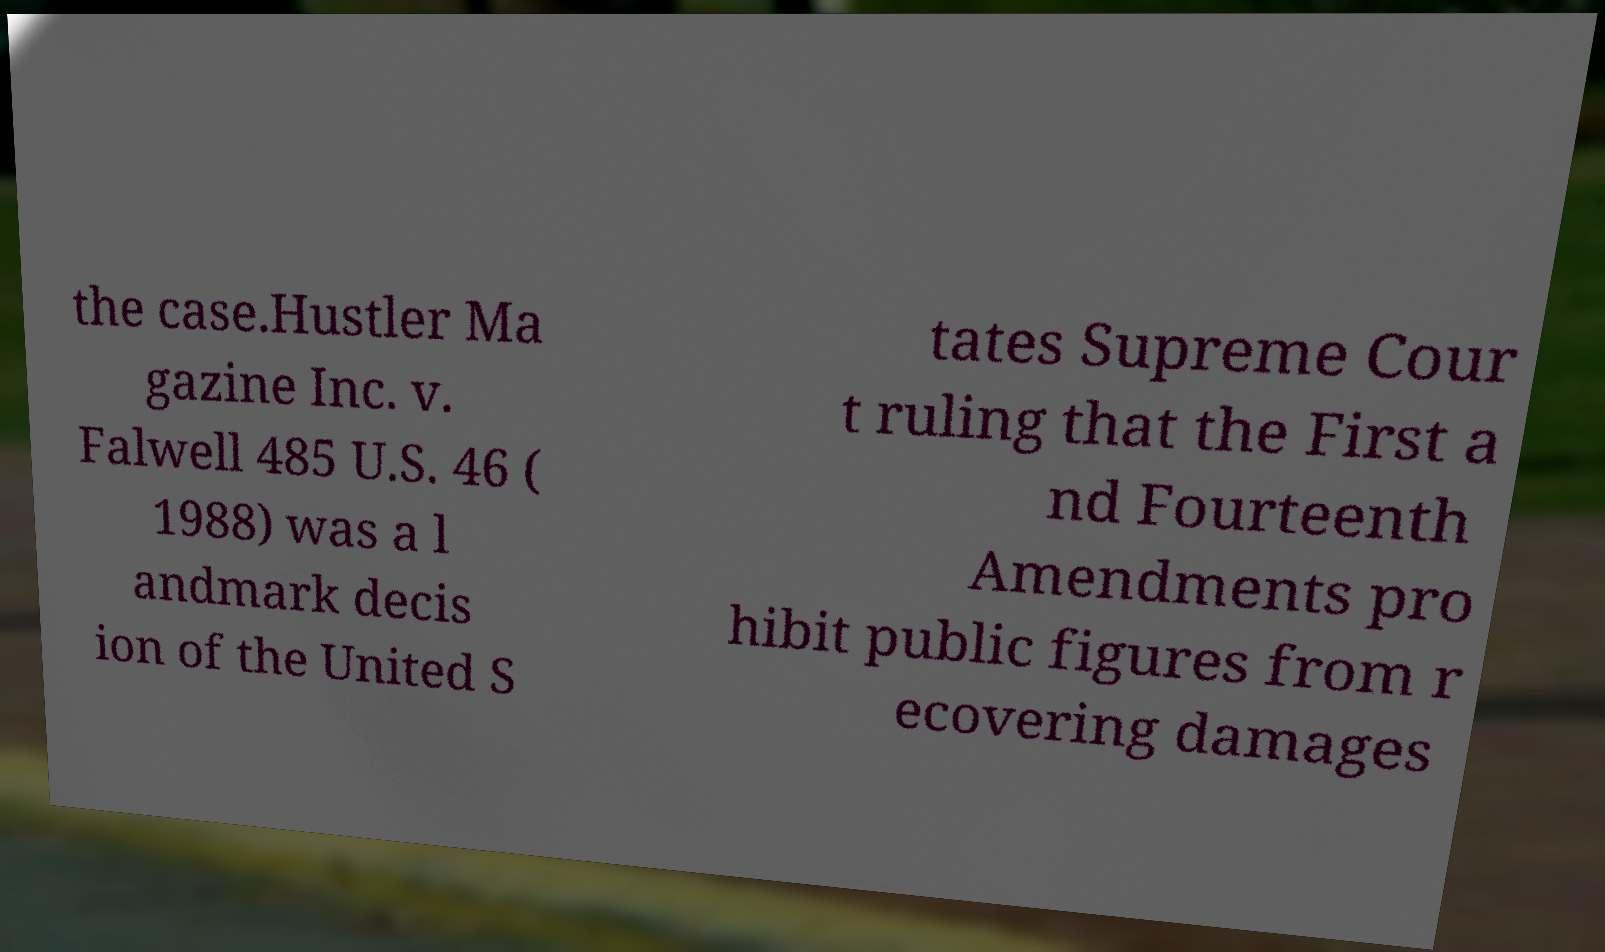Could you extract and type out the text from this image? the case.Hustler Ma gazine Inc. v. Falwell 485 U.S. 46 ( 1988) was a l andmark decis ion of the United S tates Supreme Cour t ruling that the First a nd Fourteenth Amendments pro hibit public figures from r ecovering damages 